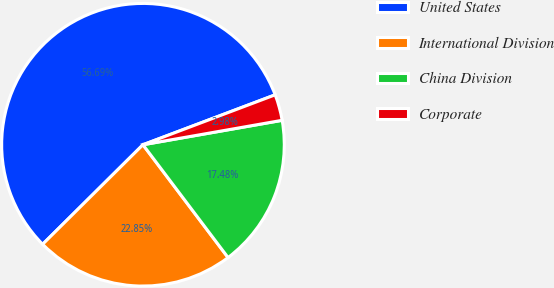Convert chart. <chart><loc_0><loc_0><loc_500><loc_500><pie_chart><fcel>United States<fcel>International Division<fcel>China Division<fcel>Corporate<nl><fcel>56.69%<fcel>22.85%<fcel>17.48%<fcel>2.98%<nl></chart> 